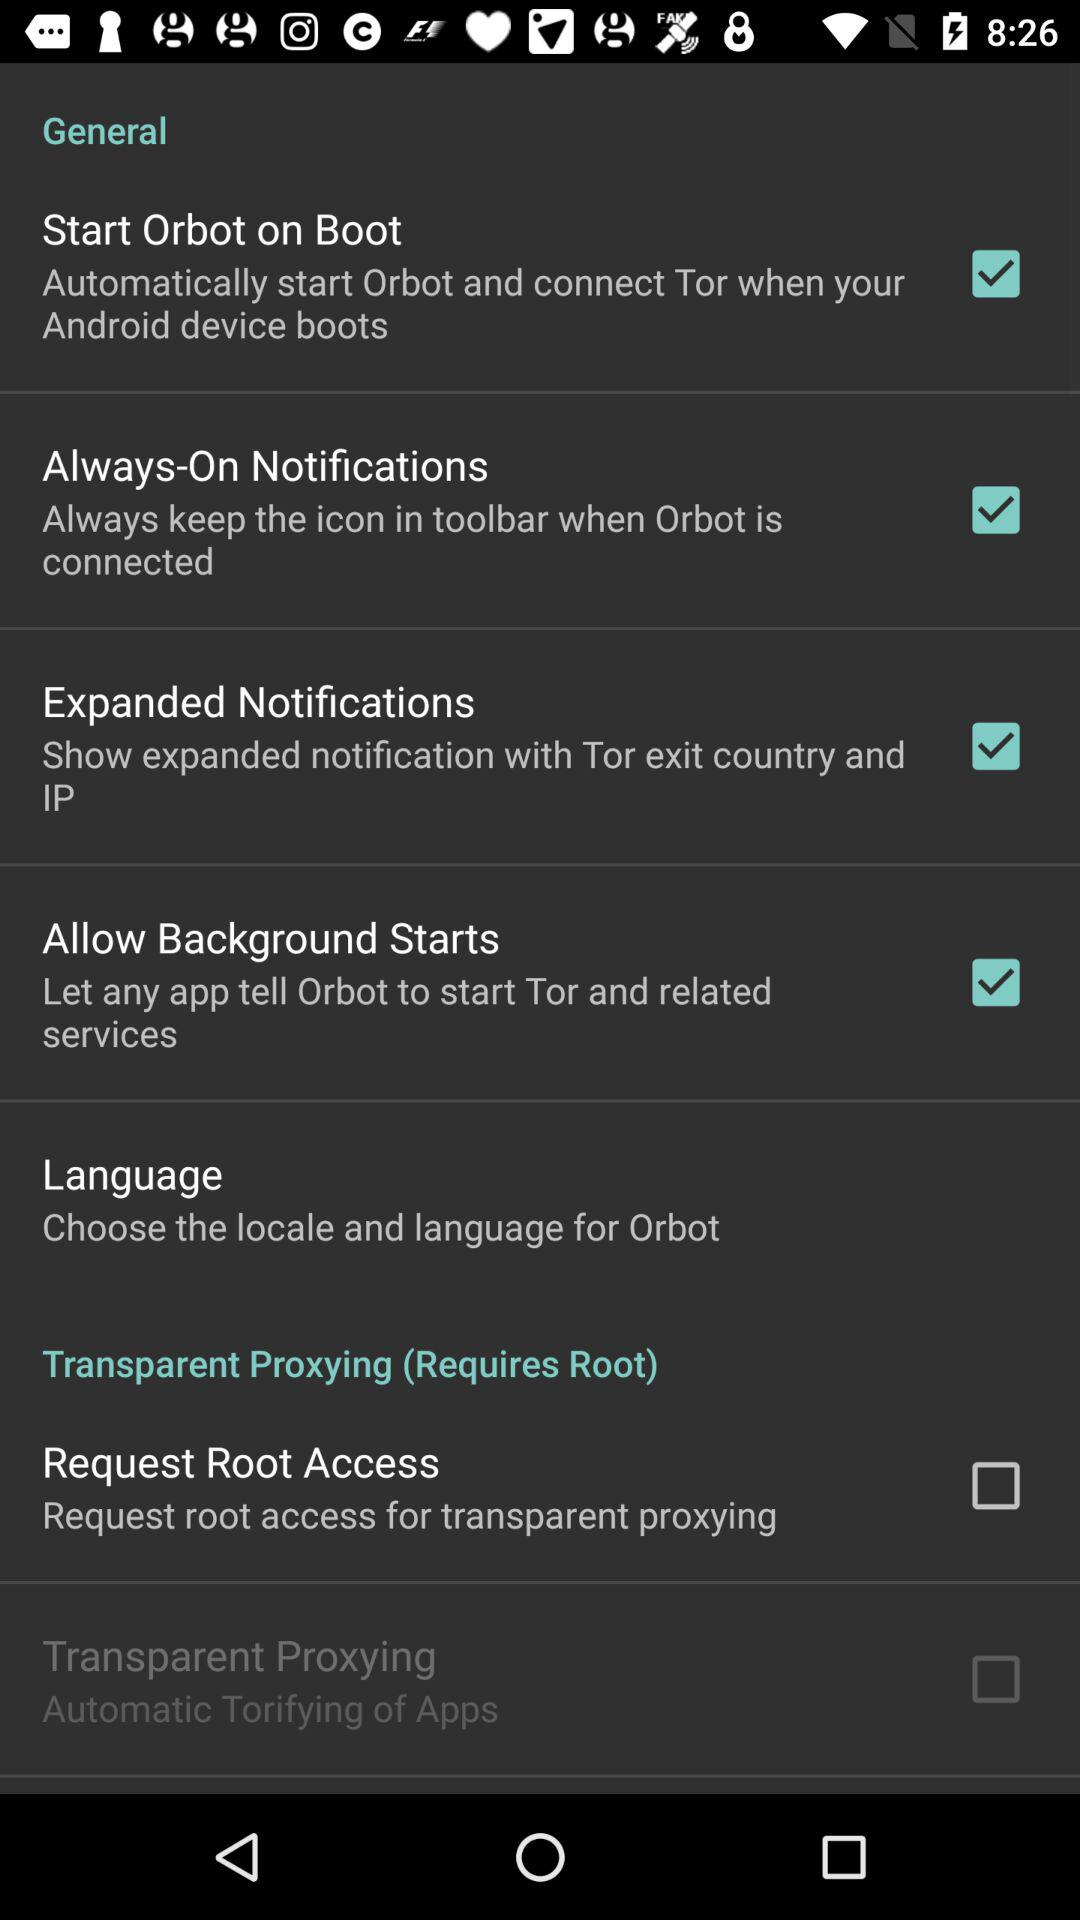How many checkboxes are in the transparent proxying section?
Answer the question using a single word or phrase. 2 